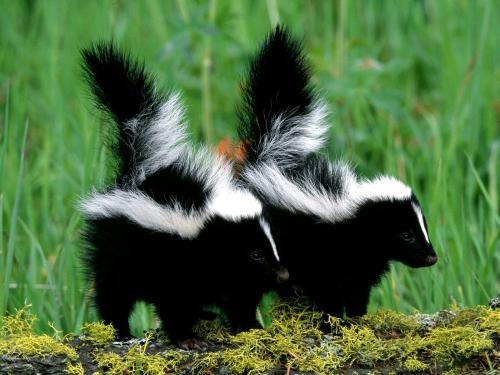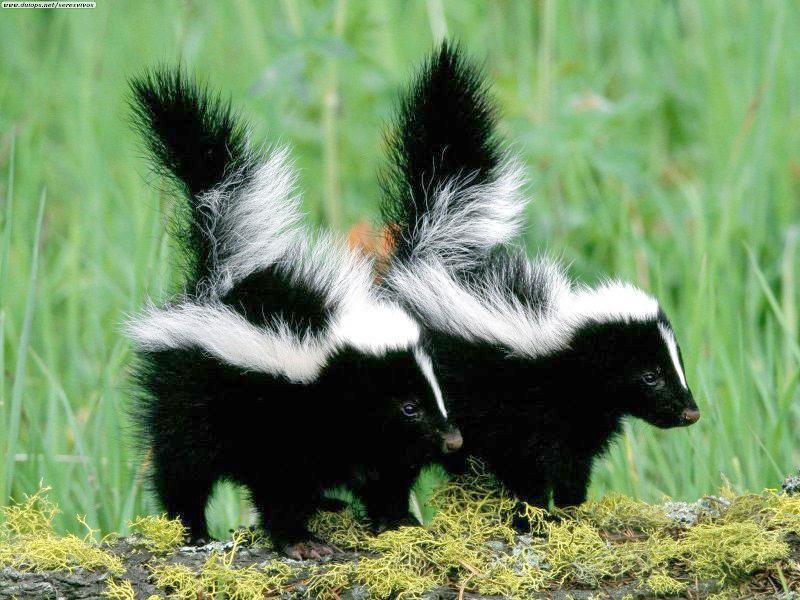The first image is the image on the left, the second image is the image on the right. Examine the images to the left and right. Is the description "A skunk is facing to the right in one image and a skunk is facing to the left in another image." accurate? Answer yes or no. No. 